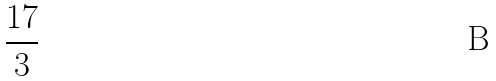Convert formula to latex. <formula><loc_0><loc_0><loc_500><loc_500>\frac { 1 7 } { 3 }</formula> 